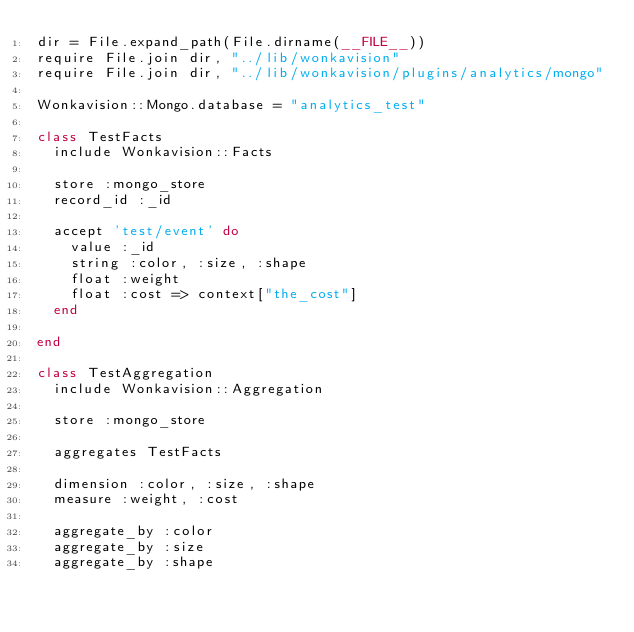<code> <loc_0><loc_0><loc_500><loc_500><_Ruby_>dir = File.expand_path(File.dirname(__FILE__))
require File.join dir, "../lib/wonkavision"
require File.join dir, "../lib/wonkavision/plugins/analytics/mongo"

Wonkavision::Mongo.database = "analytics_test"

class TestFacts
  include Wonkavision::Facts

  store :mongo_store
  record_id :_id

  accept 'test/event' do
    value :_id
    string :color, :size, :shape
    float :weight
    float :cost => context["the_cost"]
  end

end

class TestAggregation
  include Wonkavision::Aggregation

  store :mongo_store

  aggregates TestFacts

  dimension :color, :size, :shape
  measure :weight, :cost

  aggregate_by :color
  aggregate_by :size
  aggregate_by :shape</code> 